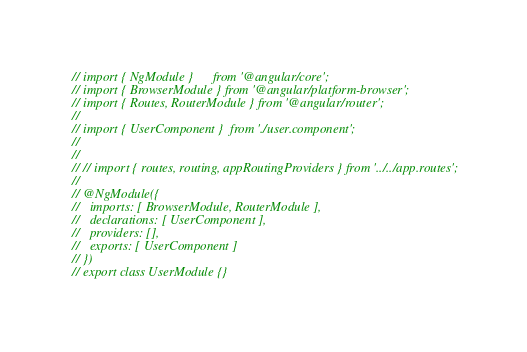<code> <loc_0><loc_0><loc_500><loc_500><_TypeScript_>// import { NgModule }      from '@angular/core';
// import { BrowserModule } from '@angular/platform-browser';
// import { Routes, RouterModule } from '@angular/router';
//
// import { UserComponent }  from './user.component';
//
//
// // import { routes, routing, appRoutingProviders } from '../../app.routes';
//
// @NgModule({
//   imports: [ BrowserModule, RouterModule ],
//   declarations: [ UserComponent ],
//   providers: [],
//   exports: [ UserComponent ]
// })
// export class UserModule {}
</code> 